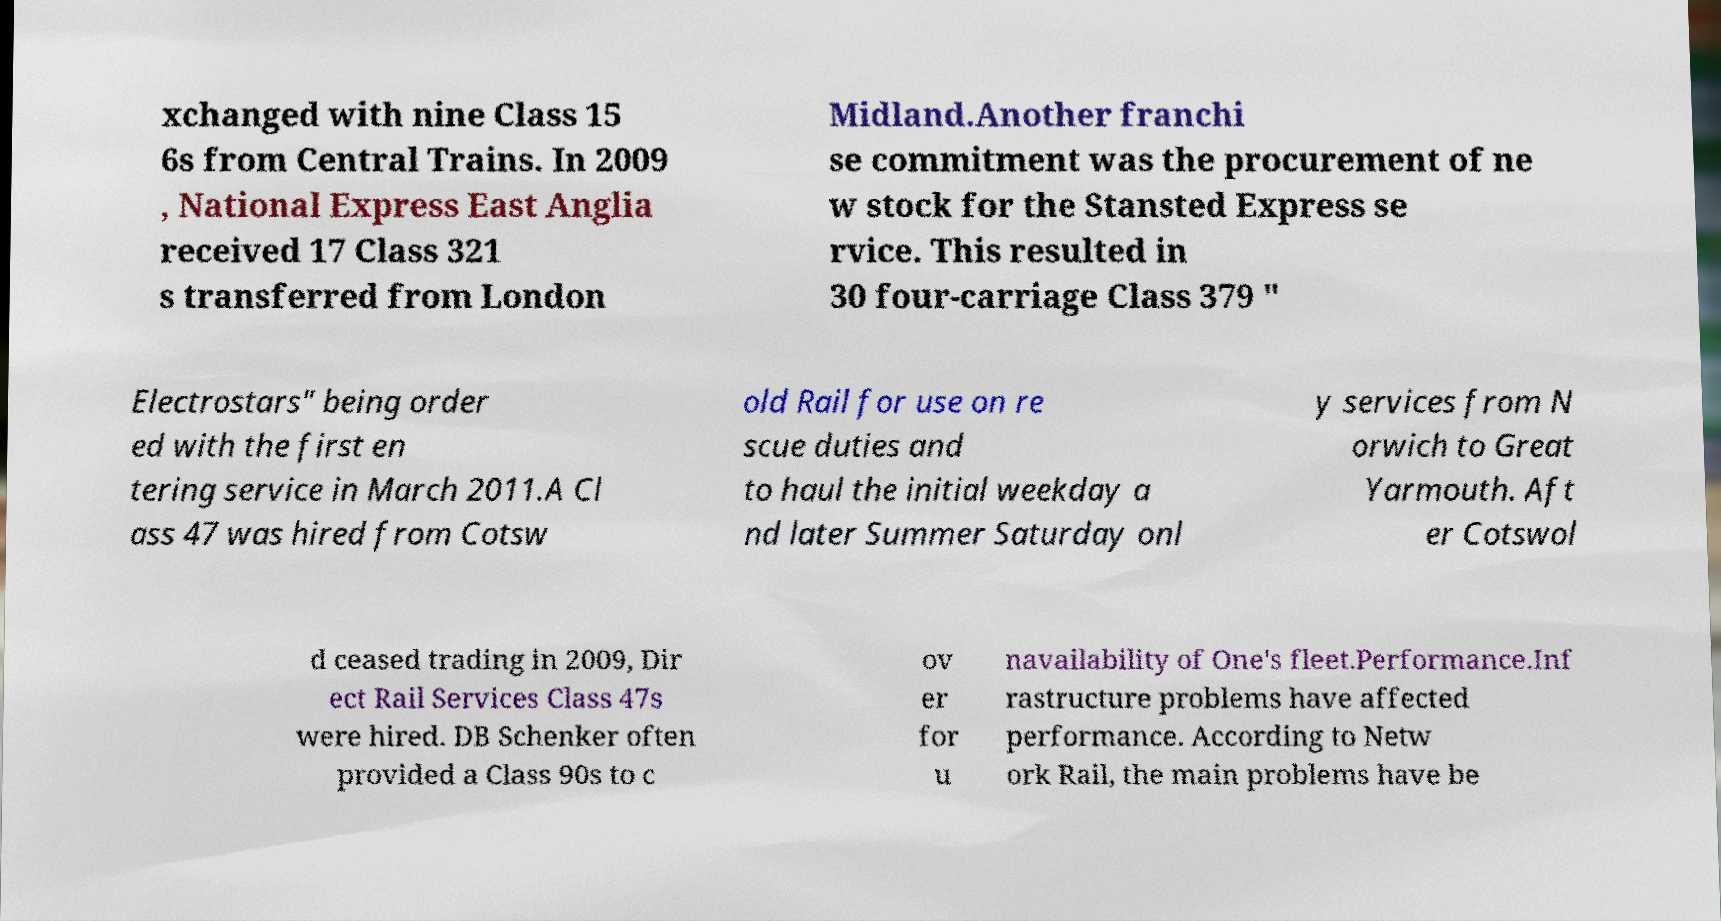There's text embedded in this image that I need extracted. Can you transcribe it verbatim? xchanged with nine Class 15 6s from Central Trains. In 2009 , National Express East Anglia received 17 Class 321 s transferred from London Midland.Another franchi se commitment was the procurement of ne w stock for the Stansted Express se rvice. This resulted in 30 four-carriage Class 379 " Electrostars" being order ed with the first en tering service in March 2011.A Cl ass 47 was hired from Cotsw old Rail for use on re scue duties and to haul the initial weekday a nd later Summer Saturday onl y services from N orwich to Great Yarmouth. Aft er Cotswol d ceased trading in 2009, Dir ect Rail Services Class 47s were hired. DB Schenker often provided a Class 90s to c ov er for u navailability of One's fleet.Performance.Inf rastructure problems have affected performance. According to Netw ork Rail, the main problems have be 